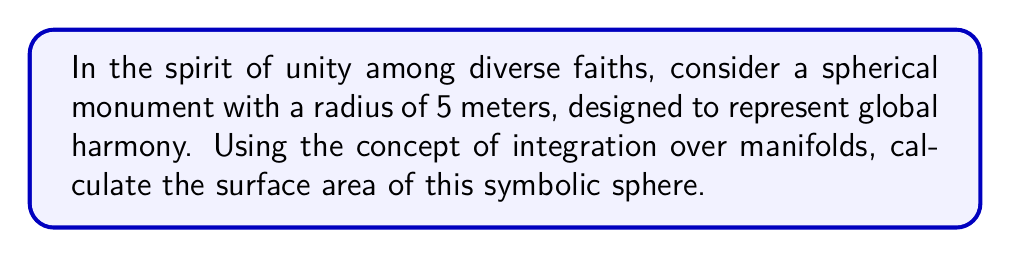Show me your answer to this math problem. To calculate the surface area of a sphere using integration over manifolds, we'll follow these steps:

1) First, recall that a sphere can be parameterized using spherical coordinates:

   $x = r \sin\theta \cos\phi$
   $y = r \sin\theta \sin\phi$
   $z = r \cos\theta$

   where $r$ is the radius, $\theta$ is the polar angle (0 to $\pi$), and $\phi$ is the azimuthal angle (0 to $2\pi$).

2) The surface area of a manifold is given by the integral:

   $$ A = \int\int_S \sqrt{EG - F^2} \, d\theta \, d\phi $$

   where $E$, $F$, and $G$ are the coefficients of the first fundamental form.

3) For a sphere, we have:

   $E = r^2$
   $F = 0$
   $G = r^2 \sin^2\theta$

4) Substituting these into our integral:

   $$ A = \int_0^{2\pi} \int_0^{\pi} \sqrt{r^2 \cdot r^2 \sin^2\theta - 0^2} \, d\theta \, d\phi $$

5) Simplifying:

   $$ A = \int_0^{2\pi} \int_0^{\pi} r^2 \sin\theta \, d\theta \, d\phi $$

6) Now, let's integrate:

   $$ A = r^2 \int_0^{2\pi} d\phi \int_0^{\pi} \sin\theta \, d\theta $$

7) Evaluating the inner integral:

   $$ A = r^2 \int_0^{2\pi} [-\cos\theta]_0^{\pi} \, d\phi = r^2 \int_0^{2\pi} 2 \, d\phi $$

8) Finally, evaluating the outer integral:

   $$ A = r^2 \cdot 2 \cdot 2\pi = 4\pi r^2 $$

9) For our specific case where $r = 5$ meters:

   $$ A = 4\pi (5^2) = 100\pi $$
Answer: The surface area of the spherical monument is $100\pi$ square meters, or approximately 314.16 square meters. 